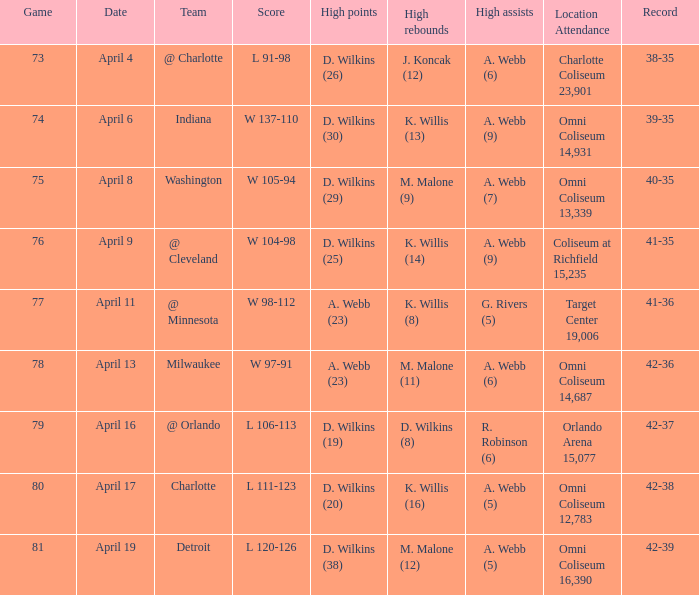Who achieved the top assists when the rival was indiana? A. Webb (9). 